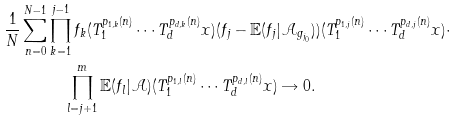Convert formula to latex. <formula><loc_0><loc_0><loc_500><loc_500>\frac { 1 } { N } \sum _ { n = 0 } ^ { N - 1 } & \prod _ { k = 1 } ^ { j - 1 } f _ { k } ( T _ { 1 } ^ { p _ { 1 , k } ( n ) } \cdots T _ { d } ^ { p _ { d , k } ( n ) } x ) ( f _ { j } - \mathbb { E } ( f _ { j } | \mathcal { A } _ { g _ { j _ { 0 } } } ) ) ( T _ { 1 } ^ { p _ { 1 , j } ( n ) } \cdots T _ { d } ^ { p _ { d , j } ( n ) } x ) \cdot \\ & \quad \prod _ { l = j + 1 } ^ { m } \mathbb { E } ( f _ { l } | \mathcal { A } ) ( T _ { 1 } ^ { p _ { 1 , l } ( n ) } \cdots T _ { d } ^ { p _ { d , l } ( n ) } x ) \rightarrow 0 .</formula> 